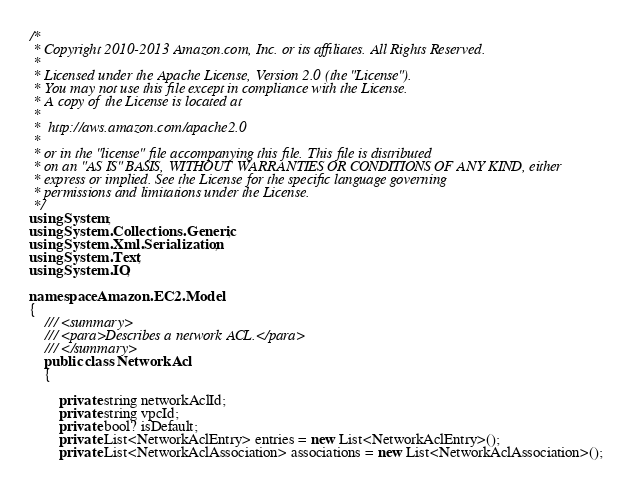Convert code to text. <code><loc_0><loc_0><loc_500><loc_500><_C#_>/*
 * Copyright 2010-2013 Amazon.com, Inc. or its affiliates. All Rights Reserved.
 * 
 * Licensed under the Apache License, Version 2.0 (the "License").
 * You may not use this file except in compliance with the License.
 * A copy of the License is located at
 * 
 *  http://aws.amazon.com/apache2.0
 * 
 * or in the "license" file accompanying this file. This file is distributed
 * on an "AS IS" BASIS, WITHOUT WARRANTIES OR CONDITIONS OF ANY KIND, either
 * express or implied. See the License for the specific language governing
 * permissions and limitations under the License.
 */
using System;
using System.Collections.Generic;
using System.Xml.Serialization;
using System.Text;
using System.IO;

namespace Amazon.EC2.Model
{
    /// <summary>
    /// <para>Describes a network ACL.</para>
    /// </summary>
    public class NetworkAcl
    {
        
        private string networkAclId;
        private string vpcId;
        private bool? isDefault;
        private List<NetworkAclEntry> entries = new List<NetworkAclEntry>();
        private List<NetworkAclAssociation> associations = new List<NetworkAclAssociation>();</code> 